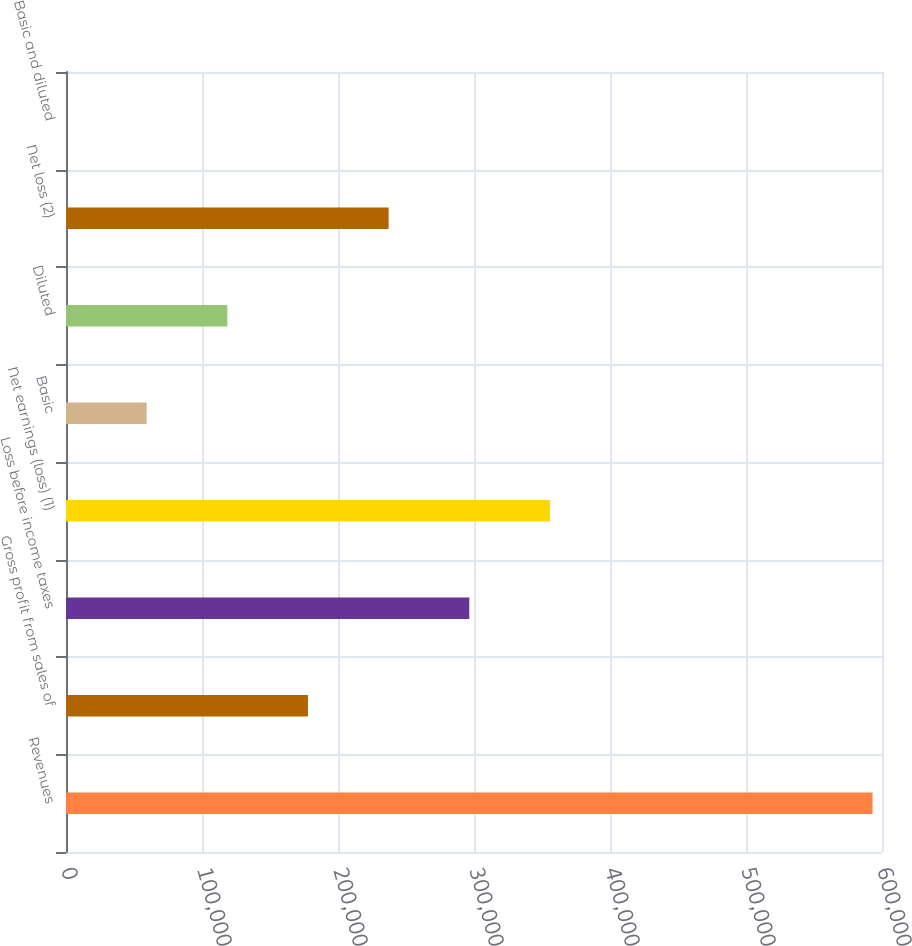Convert chart to OTSL. <chart><loc_0><loc_0><loc_500><loc_500><bar_chart><fcel>Revenues<fcel>Gross profit from sales of<fcel>Loss before income taxes<fcel>Net earnings (loss) (1)<fcel>Basic<fcel>Diluted<fcel>Net loss (2)<fcel>Basic and diluted<nl><fcel>593063<fcel>177919<fcel>296532<fcel>355838<fcel>59306.8<fcel>118613<fcel>237226<fcel>0.56<nl></chart> 